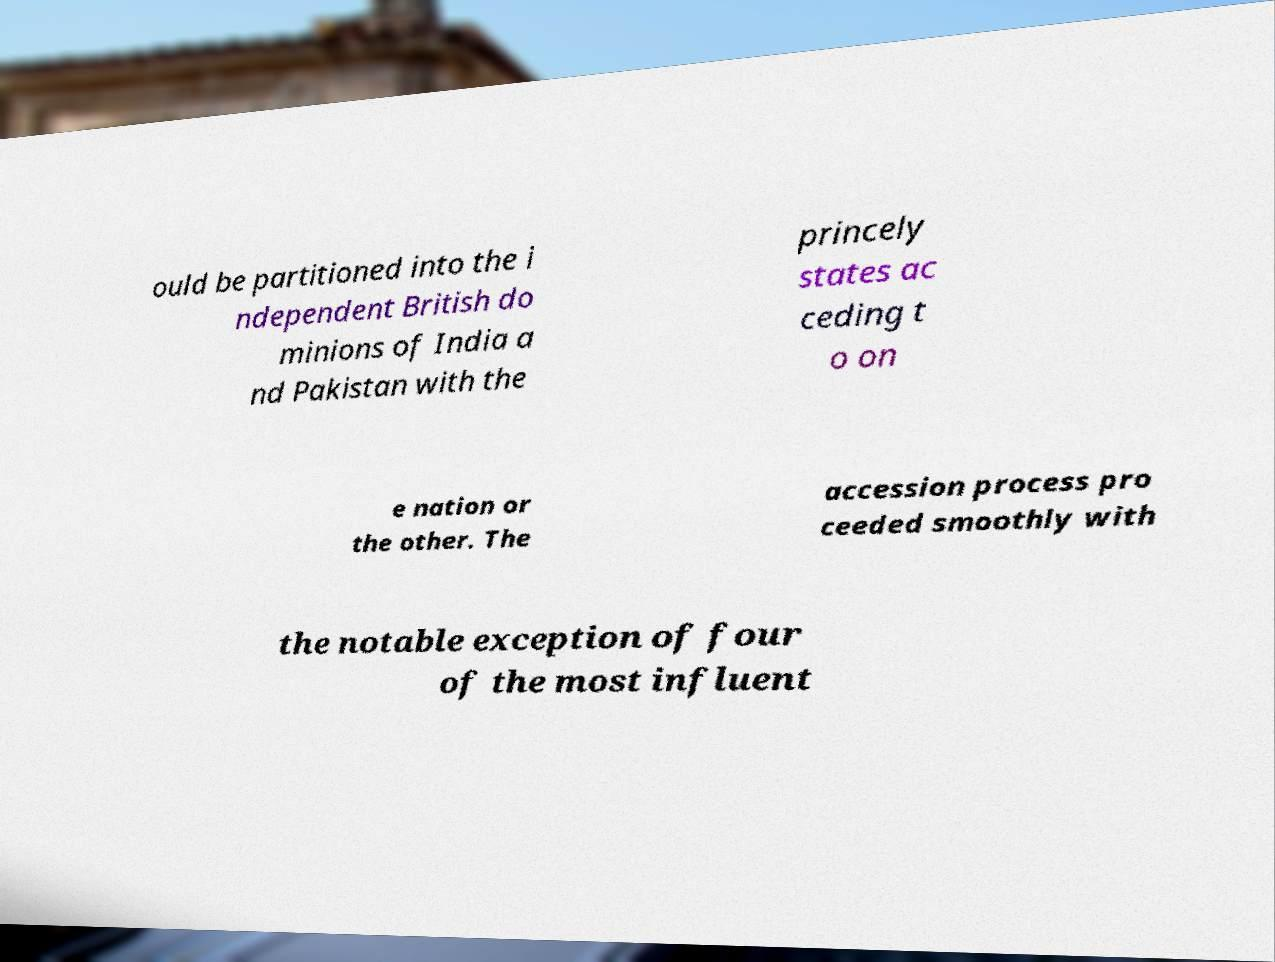Please identify and transcribe the text found in this image. ould be partitioned into the i ndependent British do minions of India a nd Pakistan with the princely states ac ceding t o on e nation or the other. The accession process pro ceeded smoothly with the notable exception of four of the most influent 